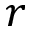Convert formula to latex. <formula><loc_0><loc_0><loc_500><loc_500>r</formula> 